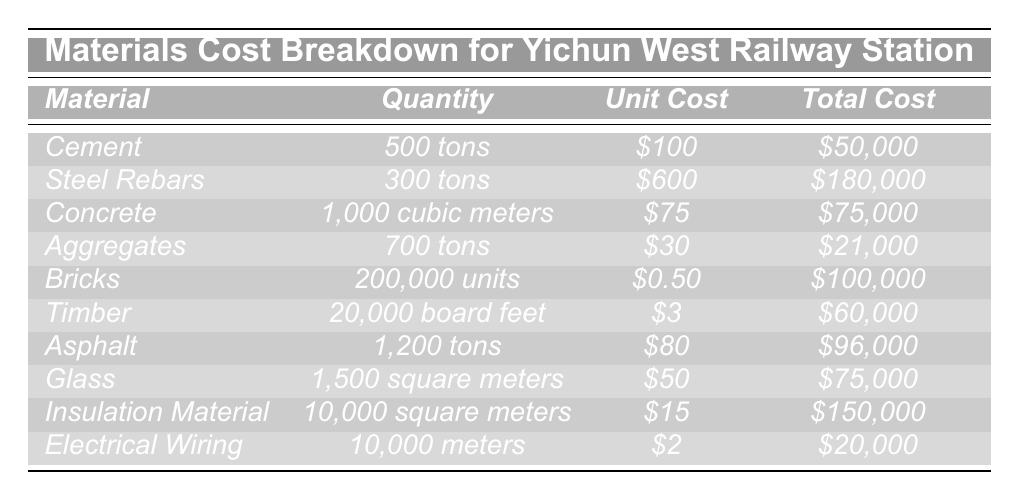What is the total cost of Concrete? The table lists the total cost for Concrete as $75,000.
Answer: $75,000 How many tons of Steel Rebars were used? The table indicates that 300 tons of Steel Rebars were used for the construction.
Answer: 300 tons What is the unit cost of Bricks? The unit cost of Bricks is provided in the table as $0.50.
Answer: $0.50 What is the total cost for Electrical Wiring? The table shows the total cost for Electrical Wiring as $20,000.
Answer: $20,000 Which material has the highest total cost? By reviewing the total costs, Steel Rebars has the highest total cost at $180,000.
Answer: Steel Rebars What is the total cost of Aggregates and Asphalt combined? The total cost of Aggregates is $21,000 and for Asphalt, it is $96,000. Adding these gives $21,000 + $96,000 = $117,000.
Answer: $117,000 What is the total quantity of materials measured in tons? The quantities are: Cement (500), Steel Rebars (300), Aggregates (700), and Asphalt (1,200). Adding these gives 500 + 300 + 700 + 1,200 = 2,700 tons.
Answer: 2,700 tons Is the total cost of Insulation Material greater than the total cost of Glass? The total cost of Insulation Material is $150,000 while the total cost of Glass is $75,000. Since $150,000 > $75,000, the statement is true.
Answer: Yes What percentage of the total material cost does Timber represent? The total costs of all materials are $50,000 + $180,000 + $75,000 + $21,000 + $100,000 + $60,000 + $96,000 + $75,000 + $150,000 + $20,000 = $  857,000. Timber's total cost is $60,000. To find the percentage: ($60,000 / $857,000) * 100 ≈ 7%.
Answer: Approximately 7% What is the average unit cost of the materials listed? The unit costs are $100, $600, $75, $30, $0.50, $3, $80, $50, $15, and $2. Summing these gives $100 + $600 + $75 + $30 + $0.50 + $3 + $80 + $50 + $15 + $2 = $955. There are 10 materials so the average is $955 / 10 = $95.50.
Answer: $95.50 